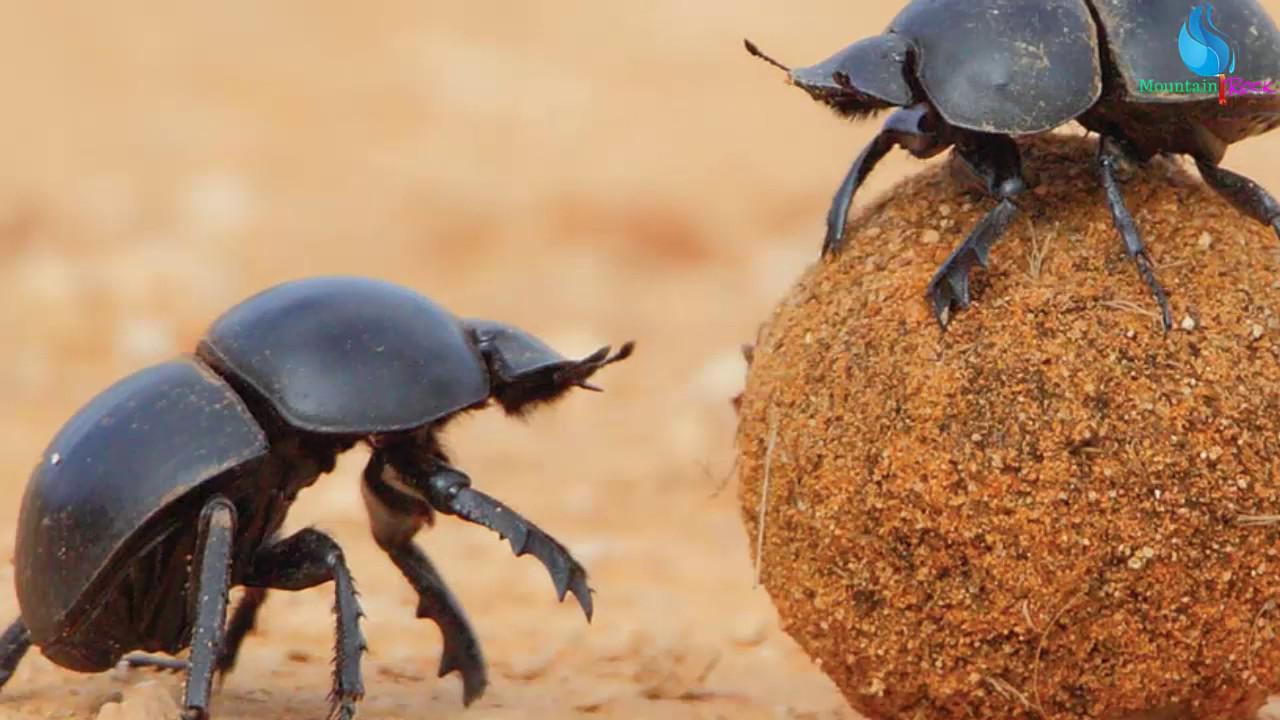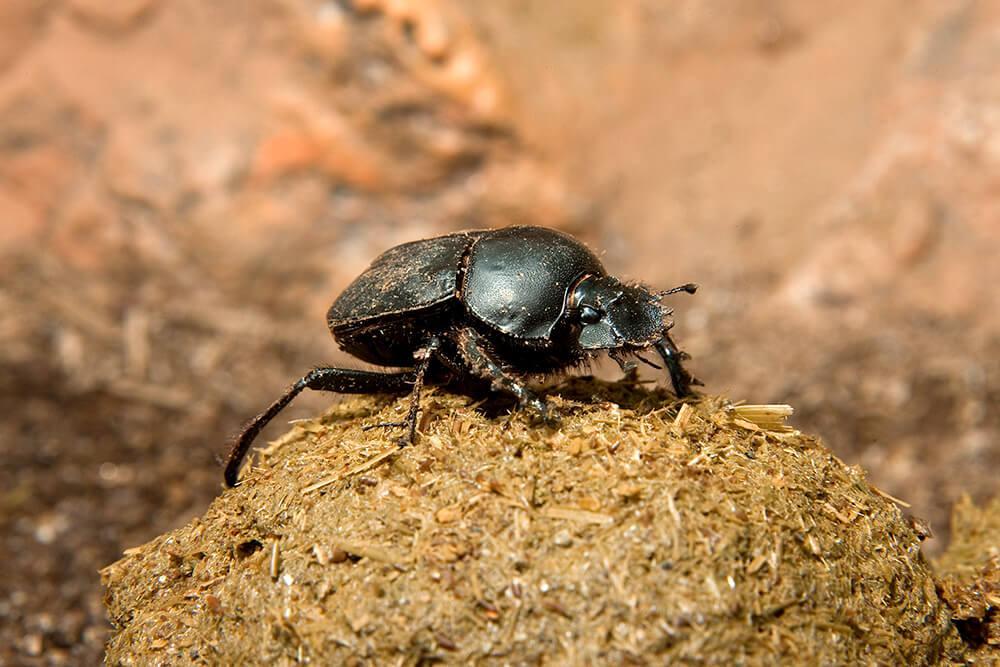The first image is the image on the left, the second image is the image on the right. For the images shown, is this caption "Each image contains a single rounded dung ball, and at least one image contains two beetles." true? Answer yes or no. Yes. 